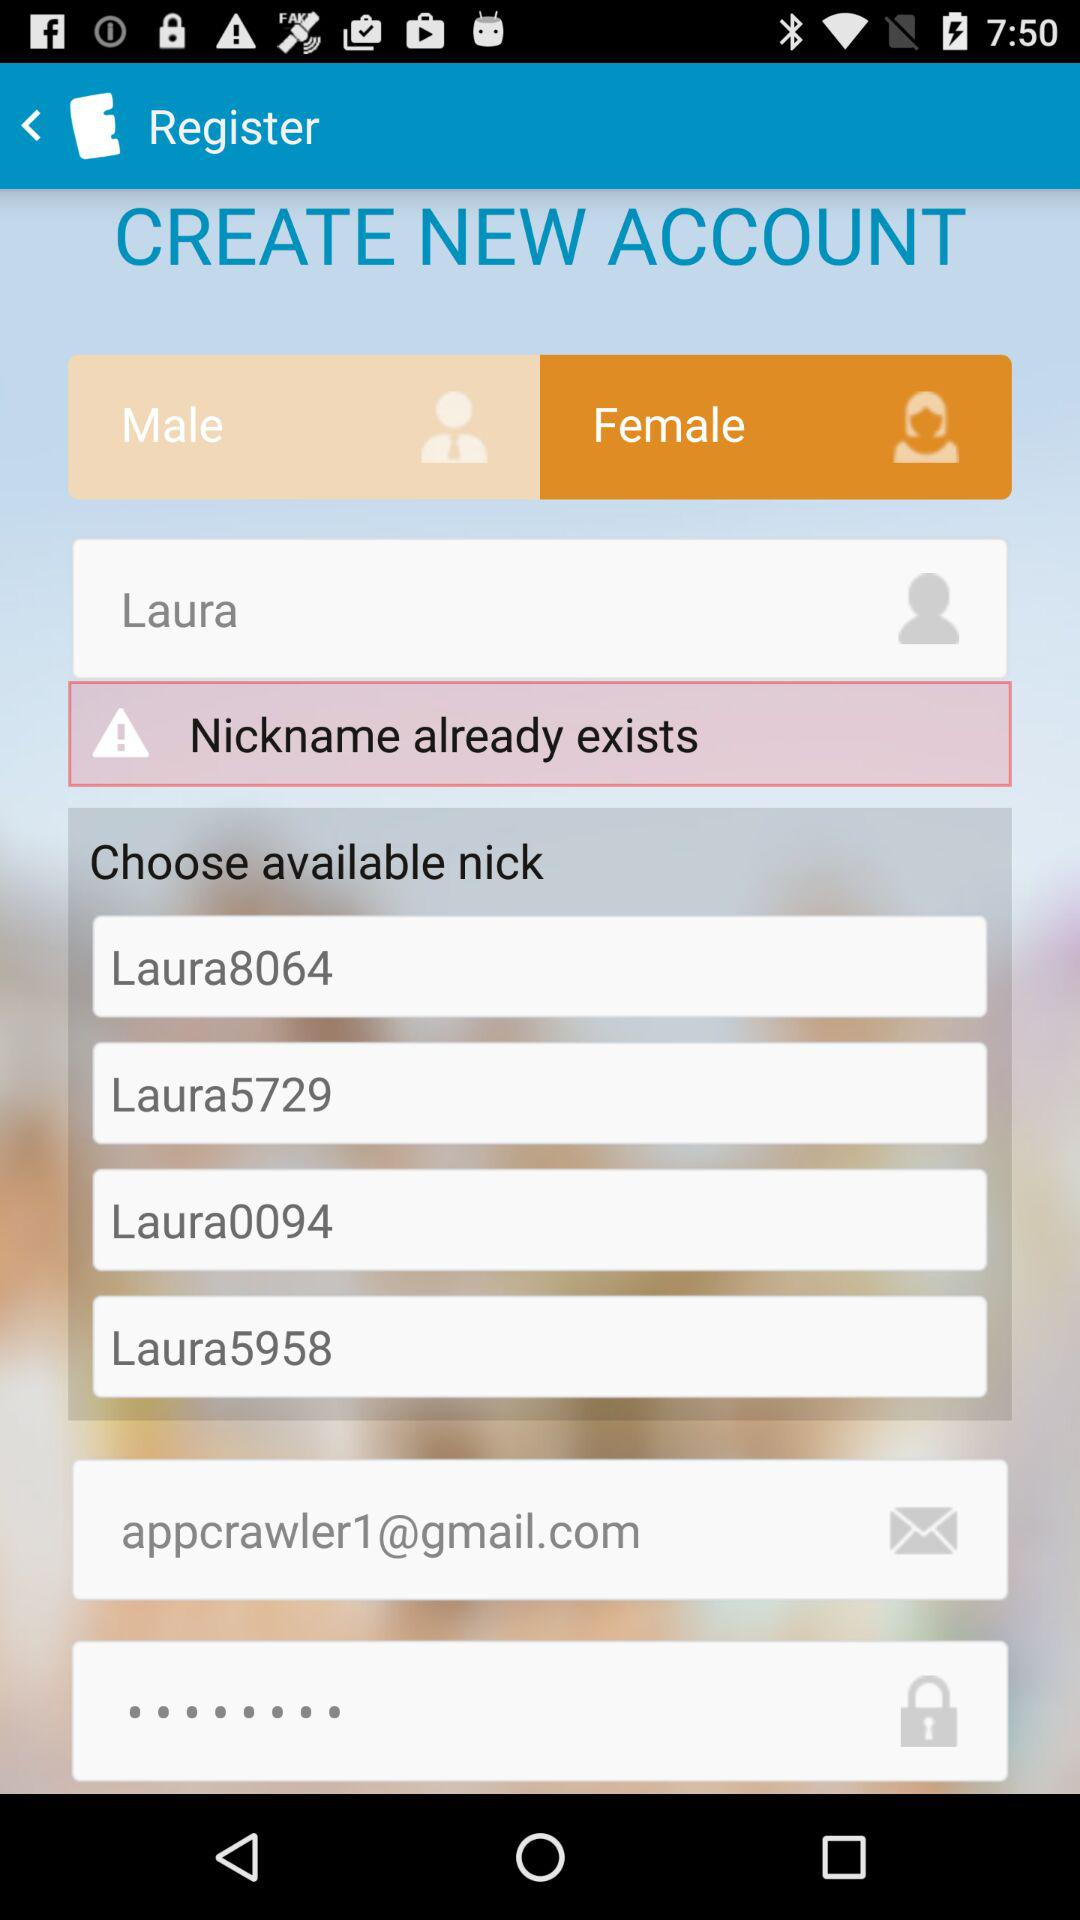What are the available nicknames that can I select? The available nicknames are "Laura8064", "Laura5729", "Laura0094" and "Laura5958". 